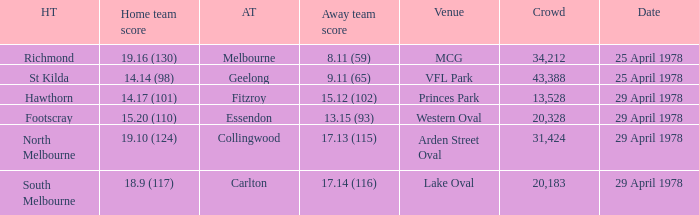What was the away team that played at Princes Park? Fitzroy. 